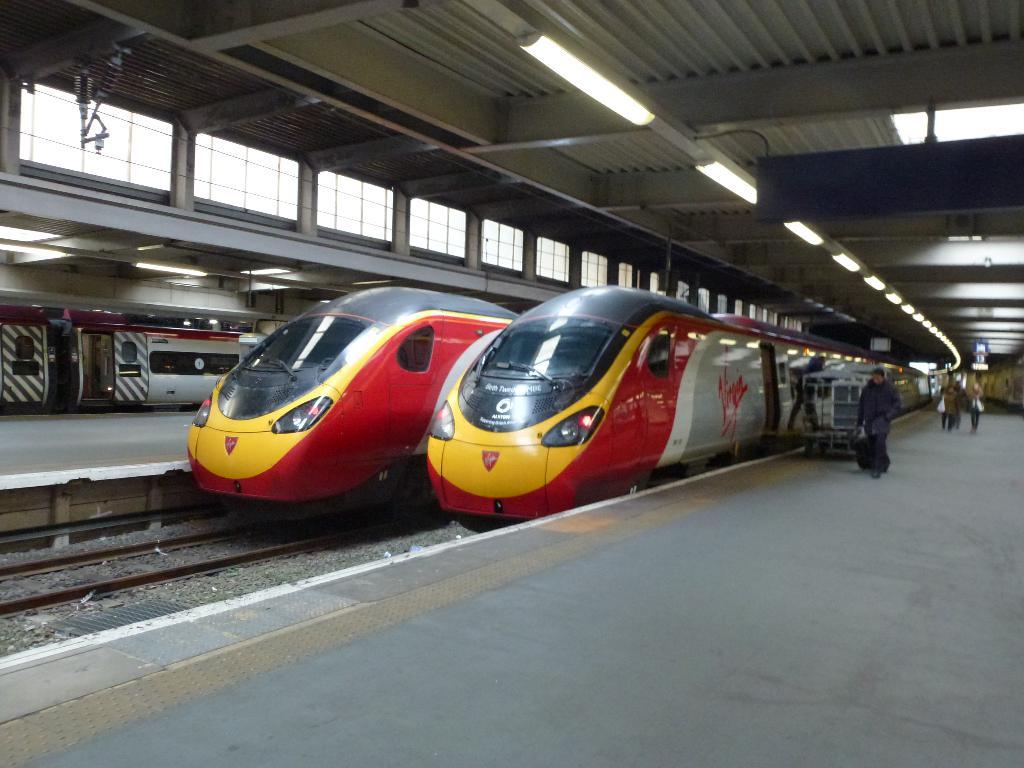Which company is featured on the train decor?
Make the answer very short. Virgin. 